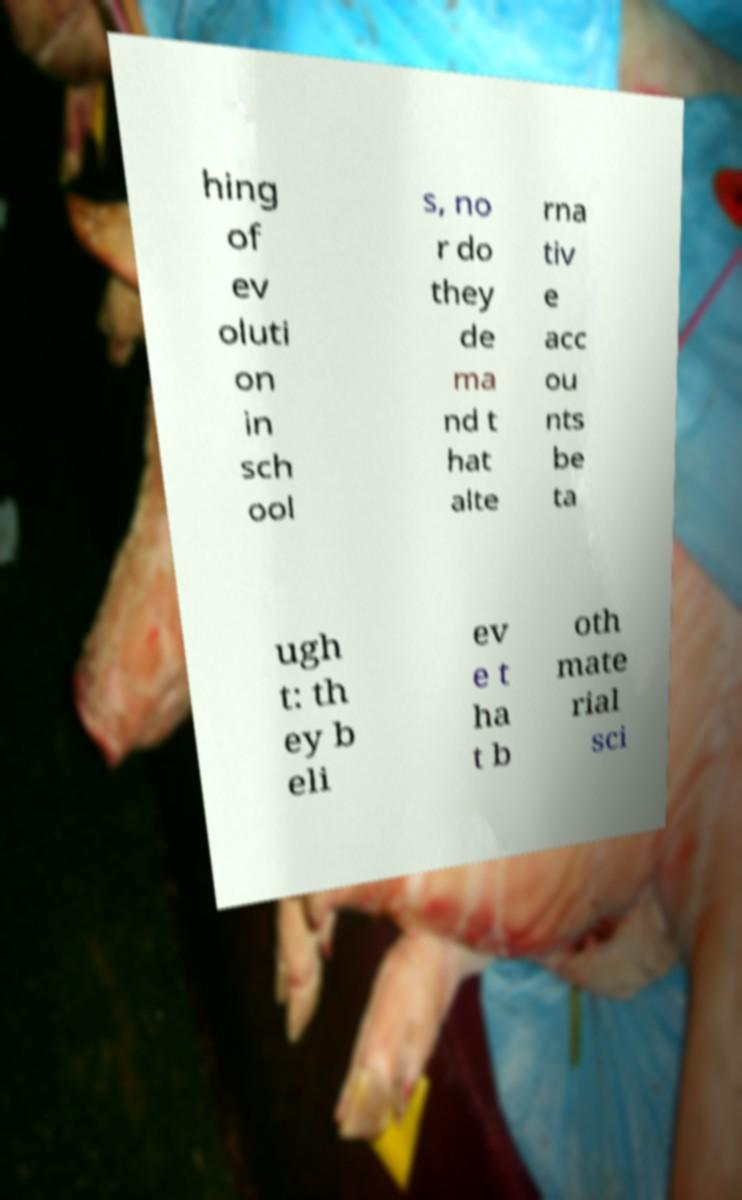Please identify and transcribe the text found in this image. hing of ev oluti on in sch ool s, no r do they de ma nd t hat alte rna tiv e acc ou nts be ta ugh t: th ey b eli ev e t ha t b oth mate rial sci 